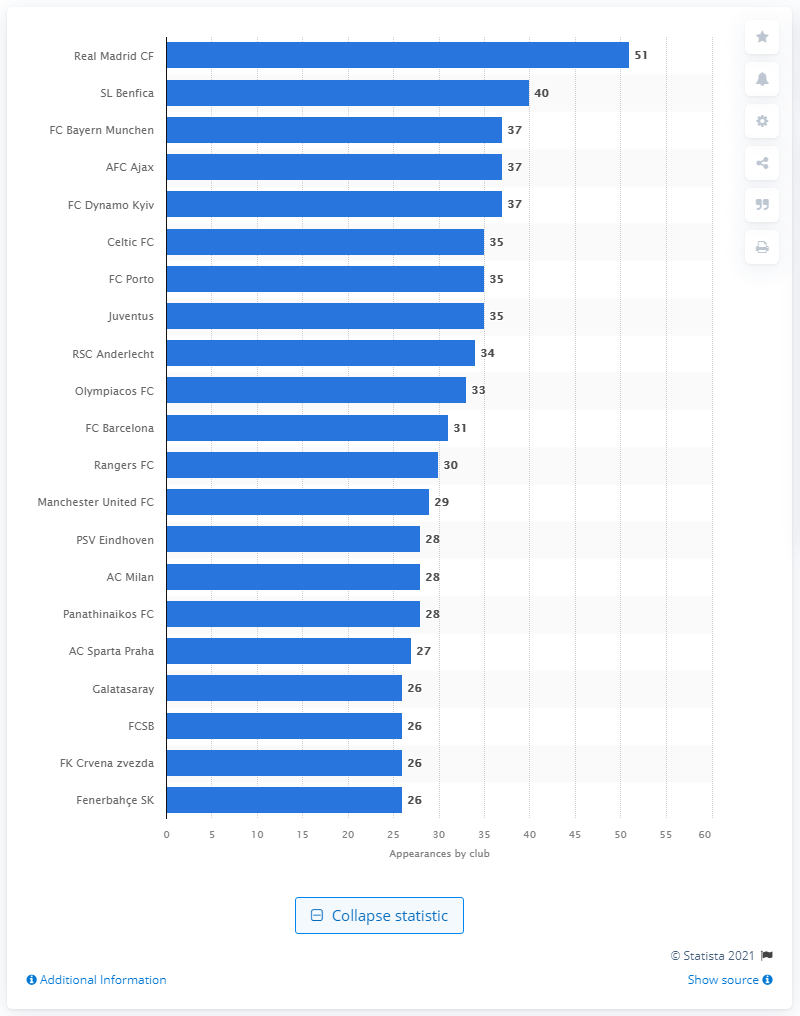Identify some key points in this picture. Real Madrid has played in the Champions League a total of 51 times. 